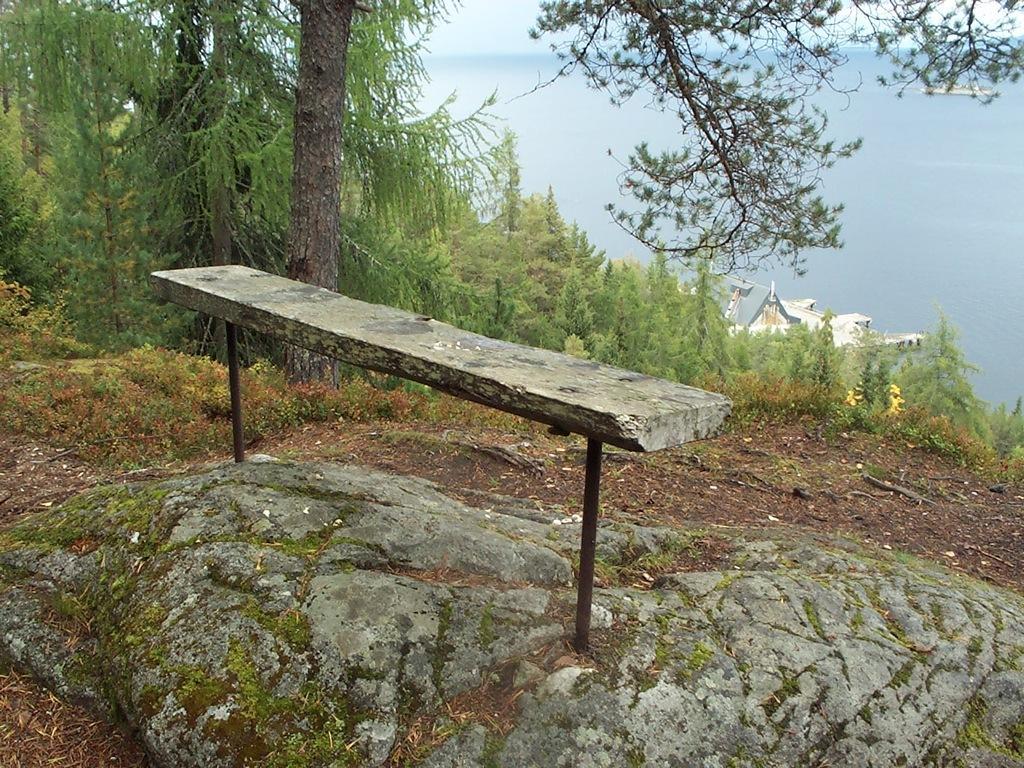Describe this image in one or two sentences. In this image I can see few trees, house, water, rock and the concrete-table. 